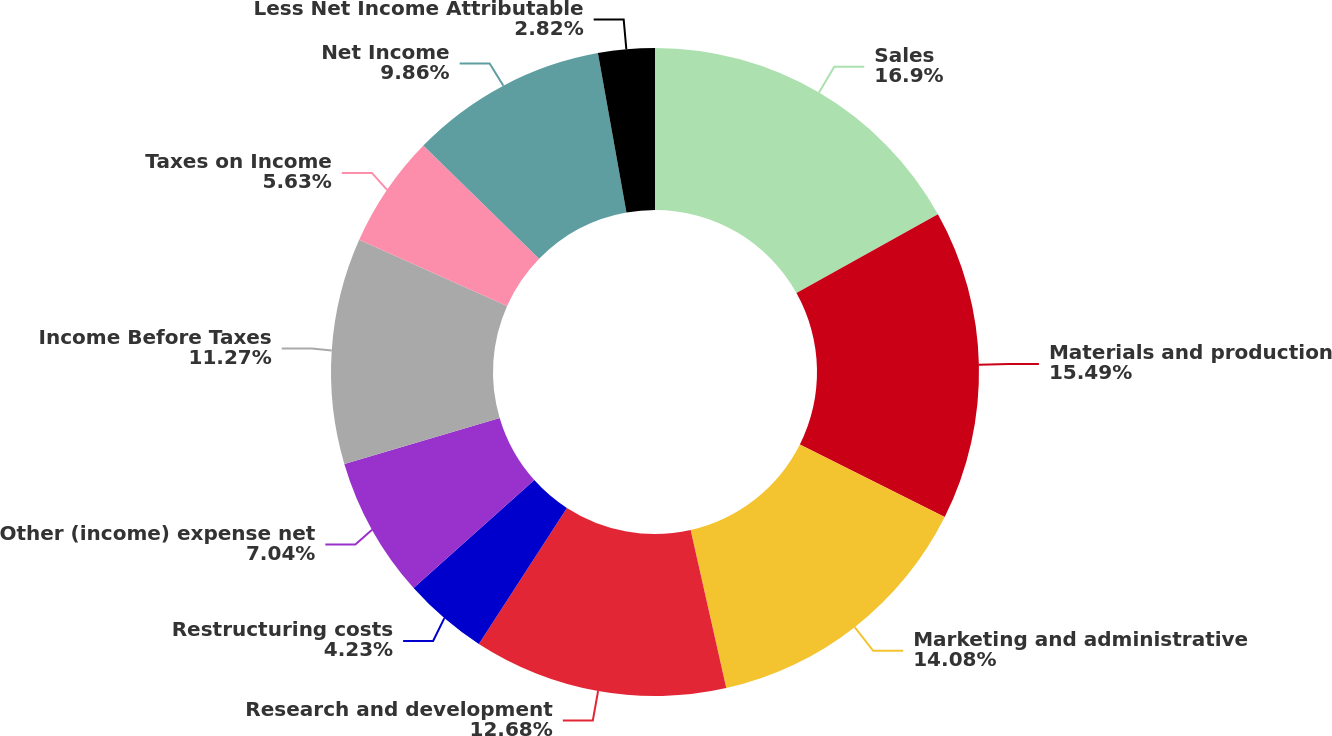Convert chart. <chart><loc_0><loc_0><loc_500><loc_500><pie_chart><fcel>Sales<fcel>Materials and production<fcel>Marketing and administrative<fcel>Research and development<fcel>Restructuring costs<fcel>Other (income) expense net<fcel>Income Before Taxes<fcel>Taxes on Income<fcel>Net Income<fcel>Less Net Income Attributable<nl><fcel>16.9%<fcel>15.49%<fcel>14.08%<fcel>12.68%<fcel>4.23%<fcel>7.04%<fcel>11.27%<fcel>5.63%<fcel>9.86%<fcel>2.82%<nl></chart> 